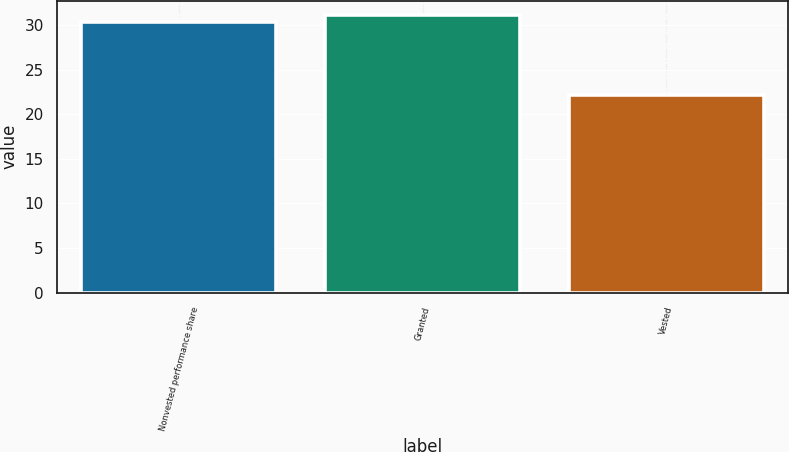Convert chart. <chart><loc_0><loc_0><loc_500><loc_500><bar_chart><fcel>Nonvested performance share<fcel>Granted<fcel>Vested<nl><fcel>30.3<fcel>31.15<fcel>22.21<nl></chart> 